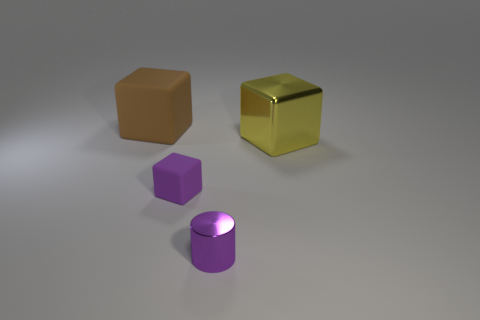How many objects are behind the tiny purple metallic cylinder and to the left of the shiny cube?
Your answer should be compact. 2. Is the size of the shiny cylinder the same as the purple rubber cube?
Your answer should be very brief. Yes. There is a rubber object behind the yellow block; is its size the same as the purple metal cylinder?
Make the answer very short. No. There is a thing that is on the right side of the small cylinder; what color is it?
Your answer should be very brief. Yellow. How many brown things are there?
Give a very brief answer. 1. There is a large yellow object that is the same material as the tiny purple cylinder; what is its shape?
Keep it short and to the point. Cube. Do the large cube left of the tiny cylinder and the matte thing that is in front of the big brown rubber cube have the same color?
Ensure brevity in your answer.  No. Are there an equal number of cubes on the right side of the big yellow metallic object and large brown shiny things?
Provide a succinct answer. Yes. There is a large metal cube; how many objects are in front of it?
Your answer should be compact. 2. What size is the brown matte object?
Provide a succinct answer. Large. 